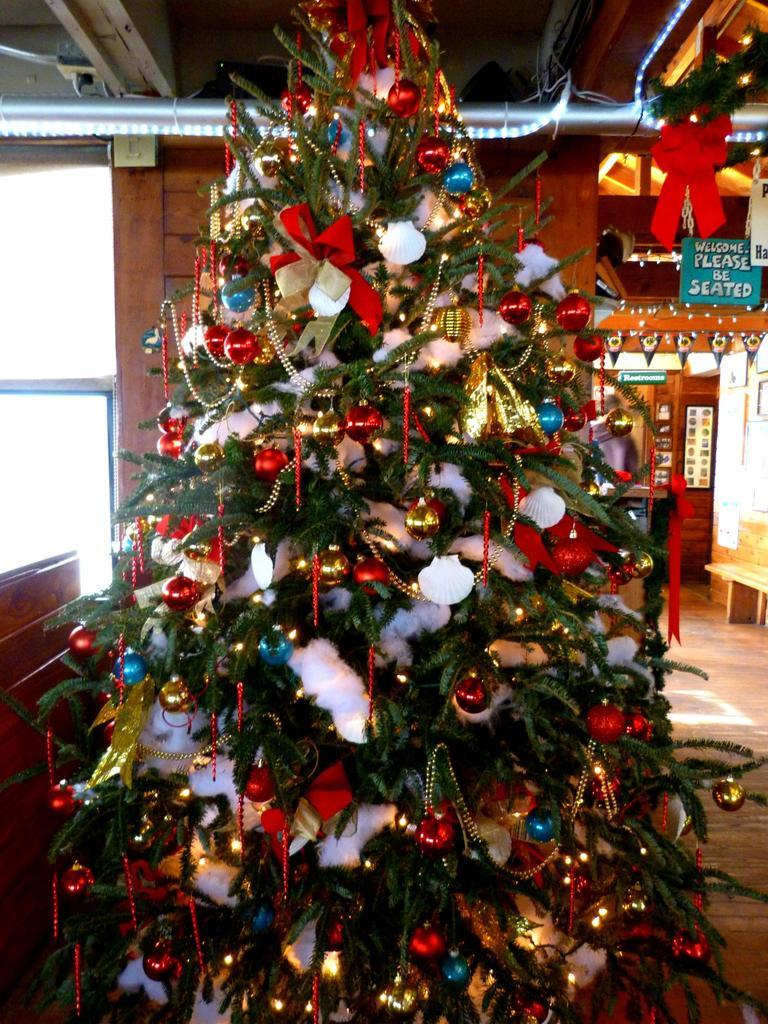What is the main object in the image? There is a Christmas tree in the image. What can be seen in the background of the image? There are lights, a board with text, and a wall in the background of the image. What type of pancake is being served at the night event in the image? There is no pancake or night event present in the image; it features a Christmas tree and background elements. 